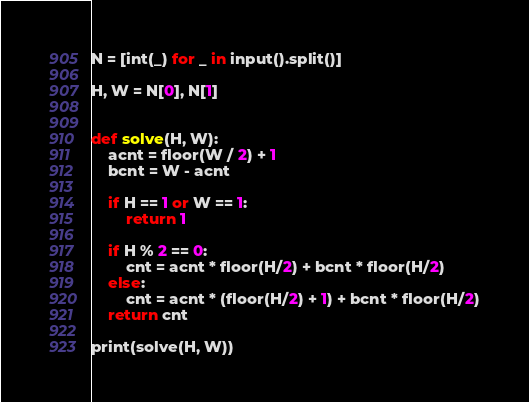Convert code to text. <code><loc_0><loc_0><loc_500><loc_500><_Python_>N = [int(_) for _ in input().split()]

H, W = N[0], N[1]


def solve(H, W):
    acnt = floor(W / 2) + 1
    bcnt = W - acnt
    
    if H == 1 or W == 1:
        return 1
    
    if H % 2 == 0:
        cnt = acnt * floor(H/2) + bcnt * floor(H/2)
    else:
        cnt = acnt * (floor(H/2) + 1) + bcnt * floor(H/2)
    return cnt

print(solve(H, W))</code> 